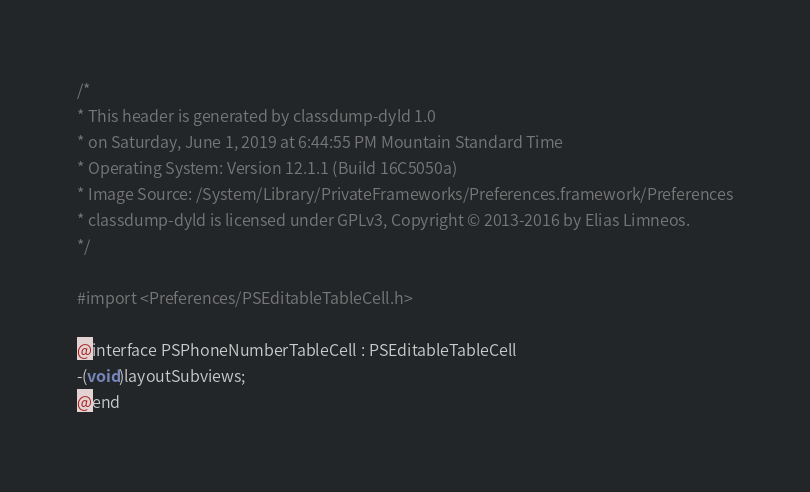<code> <loc_0><loc_0><loc_500><loc_500><_C_>/*
* This header is generated by classdump-dyld 1.0
* on Saturday, June 1, 2019 at 6:44:55 PM Mountain Standard Time
* Operating System: Version 12.1.1 (Build 16C5050a)
* Image Source: /System/Library/PrivateFrameworks/Preferences.framework/Preferences
* classdump-dyld is licensed under GPLv3, Copyright © 2013-2016 by Elias Limneos.
*/

#import <Preferences/PSEditableTableCell.h>

@interface PSPhoneNumberTableCell : PSEditableTableCell
-(void)layoutSubviews;
@end

</code> 